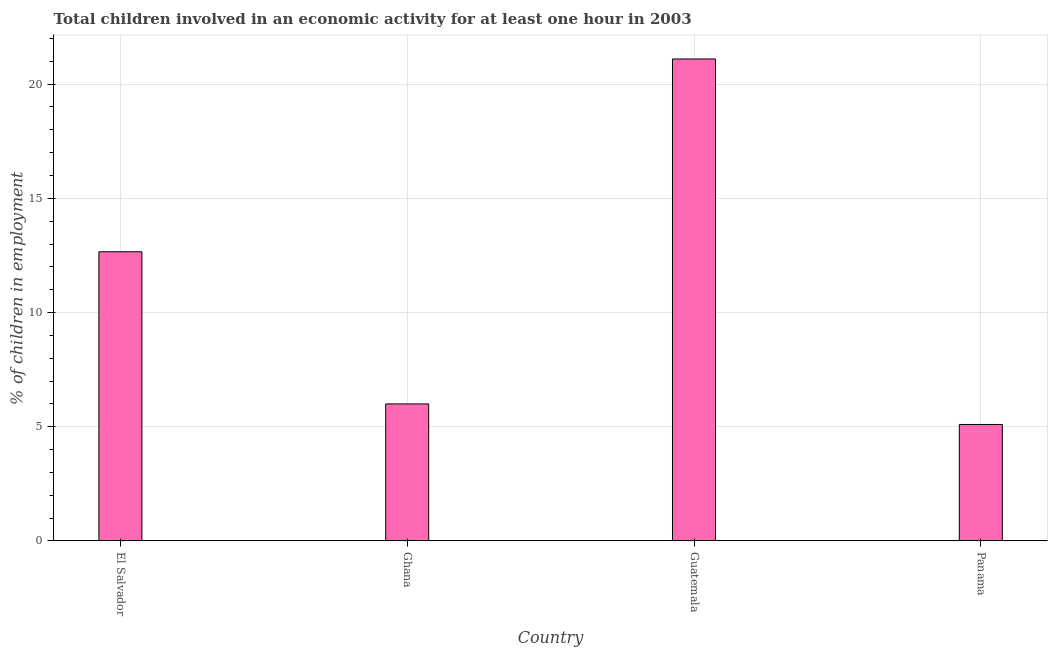Does the graph contain any zero values?
Make the answer very short. No. What is the title of the graph?
Give a very brief answer. Total children involved in an economic activity for at least one hour in 2003. What is the label or title of the X-axis?
Ensure brevity in your answer.  Country. What is the label or title of the Y-axis?
Provide a succinct answer. % of children in employment. What is the percentage of children in employment in El Salvador?
Keep it short and to the point. 12.66. Across all countries, what is the maximum percentage of children in employment?
Make the answer very short. 21.1. Across all countries, what is the minimum percentage of children in employment?
Offer a very short reply. 5.1. In which country was the percentage of children in employment maximum?
Give a very brief answer. Guatemala. In which country was the percentage of children in employment minimum?
Your response must be concise. Panama. What is the sum of the percentage of children in employment?
Offer a terse response. 44.86. What is the difference between the percentage of children in employment in Ghana and Guatemala?
Offer a terse response. -15.1. What is the average percentage of children in employment per country?
Give a very brief answer. 11.21. What is the median percentage of children in employment?
Your answer should be very brief. 9.33. What is the ratio of the percentage of children in employment in Ghana to that in Panama?
Offer a very short reply. 1.18. Is the percentage of children in employment in El Salvador less than that in Ghana?
Your answer should be very brief. No. What is the difference between the highest and the second highest percentage of children in employment?
Your response must be concise. 8.44. Is the sum of the percentage of children in employment in Ghana and Panama greater than the maximum percentage of children in employment across all countries?
Offer a terse response. No. In how many countries, is the percentage of children in employment greater than the average percentage of children in employment taken over all countries?
Give a very brief answer. 2. What is the difference between two consecutive major ticks on the Y-axis?
Your answer should be very brief. 5. Are the values on the major ticks of Y-axis written in scientific E-notation?
Offer a very short reply. No. What is the % of children in employment in El Salvador?
Your response must be concise. 12.66. What is the % of children in employment in Ghana?
Provide a short and direct response. 6. What is the % of children in employment in Guatemala?
Make the answer very short. 21.1. What is the difference between the % of children in employment in El Salvador and Ghana?
Keep it short and to the point. 6.66. What is the difference between the % of children in employment in El Salvador and Guatemala?
Your answer should be very brief. -8.44. What is the difference between the % of children in employment in El Salvador and Panama?
Make the answer very short. 7.56. What is the difference between the % of children in employment in Ghana and Guatemala?
Provide a short and direct response. -15.1. What is the ratio of the % of children in employment in El Salvador to that in Ghana?
Offer a very short reply. 2.11. What is the ratio of the % of children in employment in El Salvador to that in Panama?
Keep it short and to the point. 2.48. What is the ratio of the % of children in employment in Ghana to that in Guatemala?
Your answer should be compact. 0.28. What is the ratio of the % of children in employment in Ghana to that in Panama?
Provide a succinct answer. 1.18. What is the ratio of the % of children in employment in Guatemala to that in Panama?
Your answer should be very brief. 4.14. 